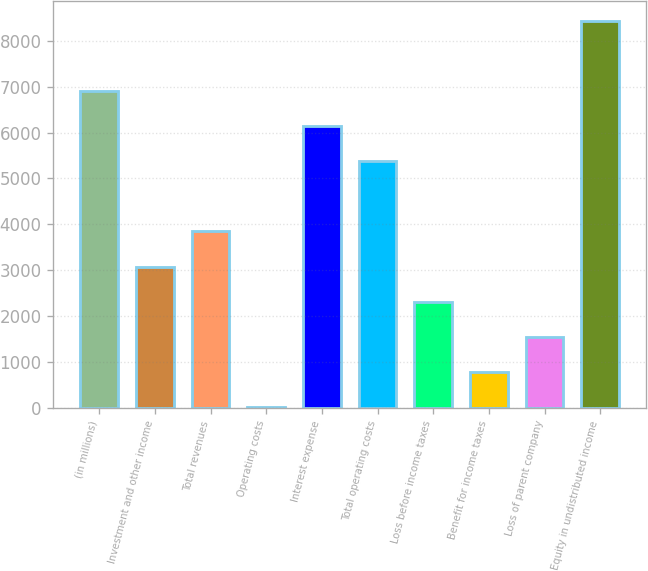<chart> <loc_0><loc_0><loc_500><loc_500><bar_chart><fcel>(in millions)<fcel>Investment and other income<fcel>Total revenues<fcel>Operating costs<fcel>Interest expense<fcel>Total operating costs<fcel>Loss before income taxes<fcel>Benefit for income taxes<fcel>Loss of parent company<fcel>Equity in undistributed income<nl><fcel>6905.2<fcel>3081.2<fcel>3846<fcel>22<fcel>6140.4<fcel>5375.6<fcel>2316.4<fcel>786.8<fcel>1551.6<fcel>8434.8<nl></chart> 